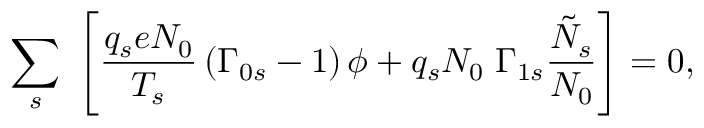Convert formula to latex. <formula><loc_0><loc_0><loc_500><loc_500>\sum _ { s } \, \left [ \frac { q _ { s } e N _ { 0 } } { T _ { s } } \left ( \Gamma _ { 0 s } - 1 \right ) \phi + q _ { s } N _ { 0 } \, \Gamma _ { 1 s } \frac { \tilde { N } _ { s } } { N _ { 0 } } \right ] = 0 ,</formula> 